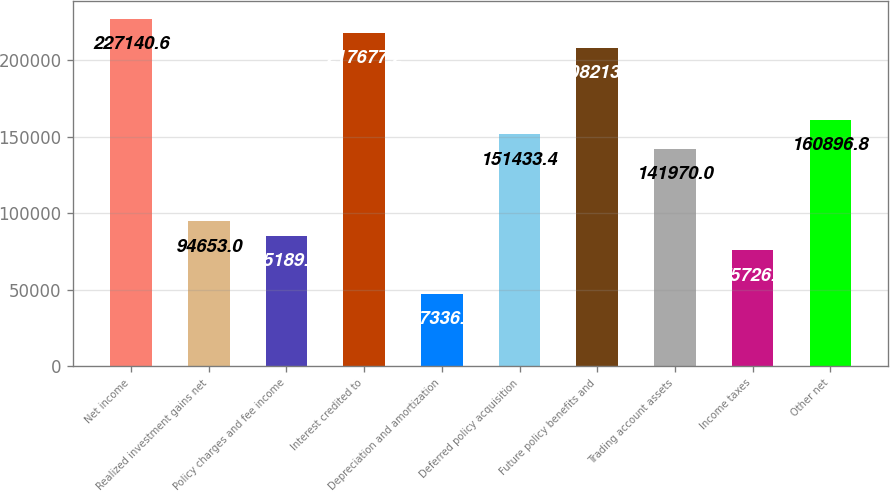Convert chart to OTSL. <chart><loc_0><loc_0><loc_500><loc_500><bar_chart><fcel>Net income<fcel>Realized investment gains net<fcel>Policy charges and fee income<fcel>Interest credited to<fcel>Depreciation and amortization<fcel>Deferred policy acquisition<fcel>Future policy benefits and<fcel>Trading account assets<fcel>Income taxes<fcel>Other net<nl><fcel>227141<fcel>94653<fcel>85189.6<fcel>217677<fcel>47336<fcel>151433<fcel>208214<fcel>141970<fcel>75726.2<fcel>160897<nl></chart> 